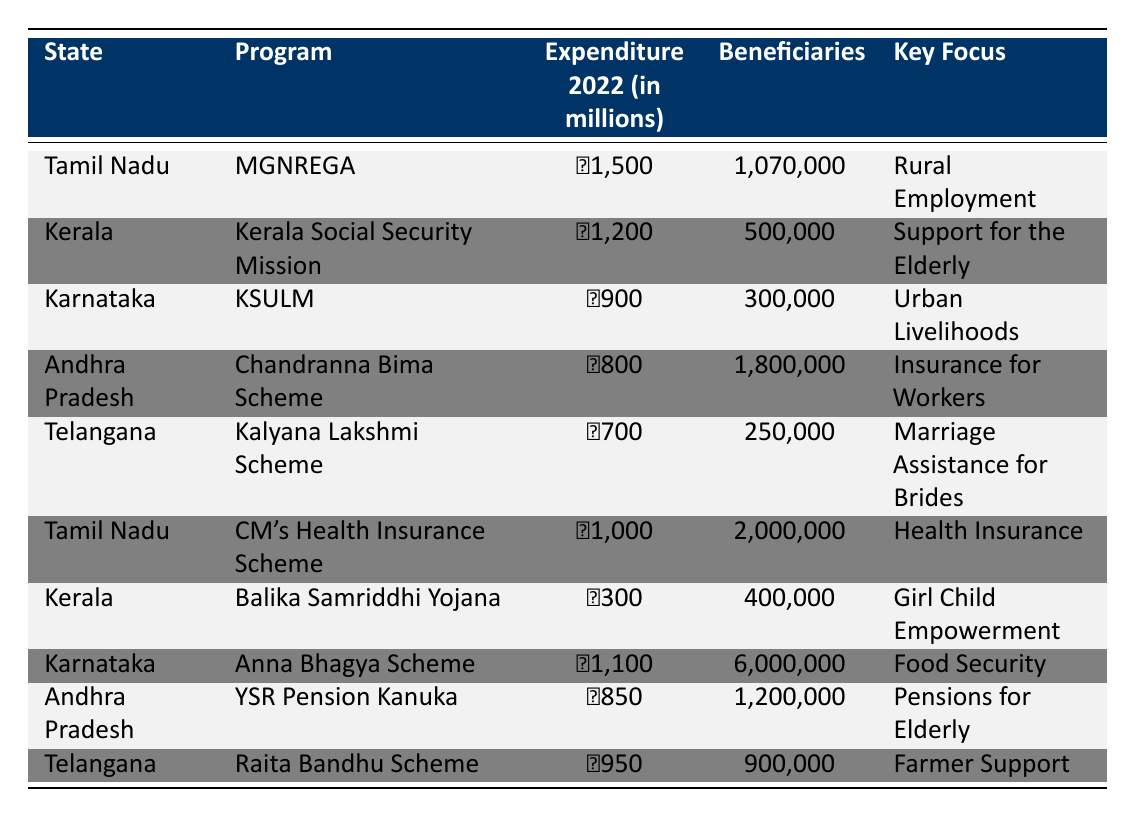What is the total expenditure on social welfare programs in Tamil Nadu for 2022? From the table, Tamil Nadu has two programs listed: MGNREGA with an expenditure of 1500 million and the CM's Health Insurance Scheme with an expenditure of 1000 million. Adding these two together gives a total of 1500 + 1000 = 2500 million.
Answer: 2500 million Which state had the highest number of beneficiaries in 2022? By examining the beneficiaries column, Andhra Pradesh's Chandranna Bima Scheme has the largest number with 1800000 beneficiaries, while Tamil Nadu's CM's Health Insurance Scheme has 2000000 beneficiaries. Comparing all values confirms Tamil Nadu has the highest.
Answer: Tamil Nadu Is the expenditure on the Kerala Social Security Mission greater than that of the Kalyana Lakshmi Scheme in Telangana? The expenditure for the Kerala Social Security Mission is 1200 million, while the Kalyana Lakshmi Scheme is 700 million. Since 1200 is greater than 700, the statement is true.
Answer: Yes What is the average expenditure on social welfare programs across all listed states? The total expenditure is the sum of all programs: 1500 + 1200 + 900 + 800 + 700 + 1000 + 300 + 1100 + 850 + 950 = 6500 million. There are 10 programs, so the average is 6500/10 = 650 million.
Answer: 650 million Does Karnataka have more beneficiaries than both Andhra Pradesh and Telangana combined? Karnataka has 300000 beneficiaries through KSULM and 6000000 through Anna Bhagya Scheme, for a total of 6300000 beneficiaries. The combined total for Andhra Pradesh (1800000) and Telangana (250000) is 2050000. Since 6300000 is greater than 2050000, the statement is true.
Answer: Yes What is the total expenditure for social welfare programs focused on health insurance? The only program focused on health insurance from the table is Tamil Nadu's CM's Health Insurance Scheme with an expenditure of 1000 million. Therefore, the total expenditure is simply 1000 million.
Answer: 1000 million Which program had the fewest beneficiaries and what was the expenditure associated with it? Balika Samriddhi Yojana in Kerala had 400000 beneficiaries, which is the smallest figure in the table, with an expenditure of 300 million. Thus, this program had both the lowest beneficiaries and a low expenditure compared to others.
Answer: Balika Samriddhi Yojana, 300 million What is the difference in beneficiaries between the Anna Bhagya Scheme in Karnataka and the Chandranna Bima Scheme in Andhra Pradesh? The Anna Bhagya Scheme has 6000000 beneficiaries, while the Chandranna Bima Scheme has 1800000 beneficiaries. The difference is calculated as 6000000 - 1800000 = 4200000.
Answer: 4200000 